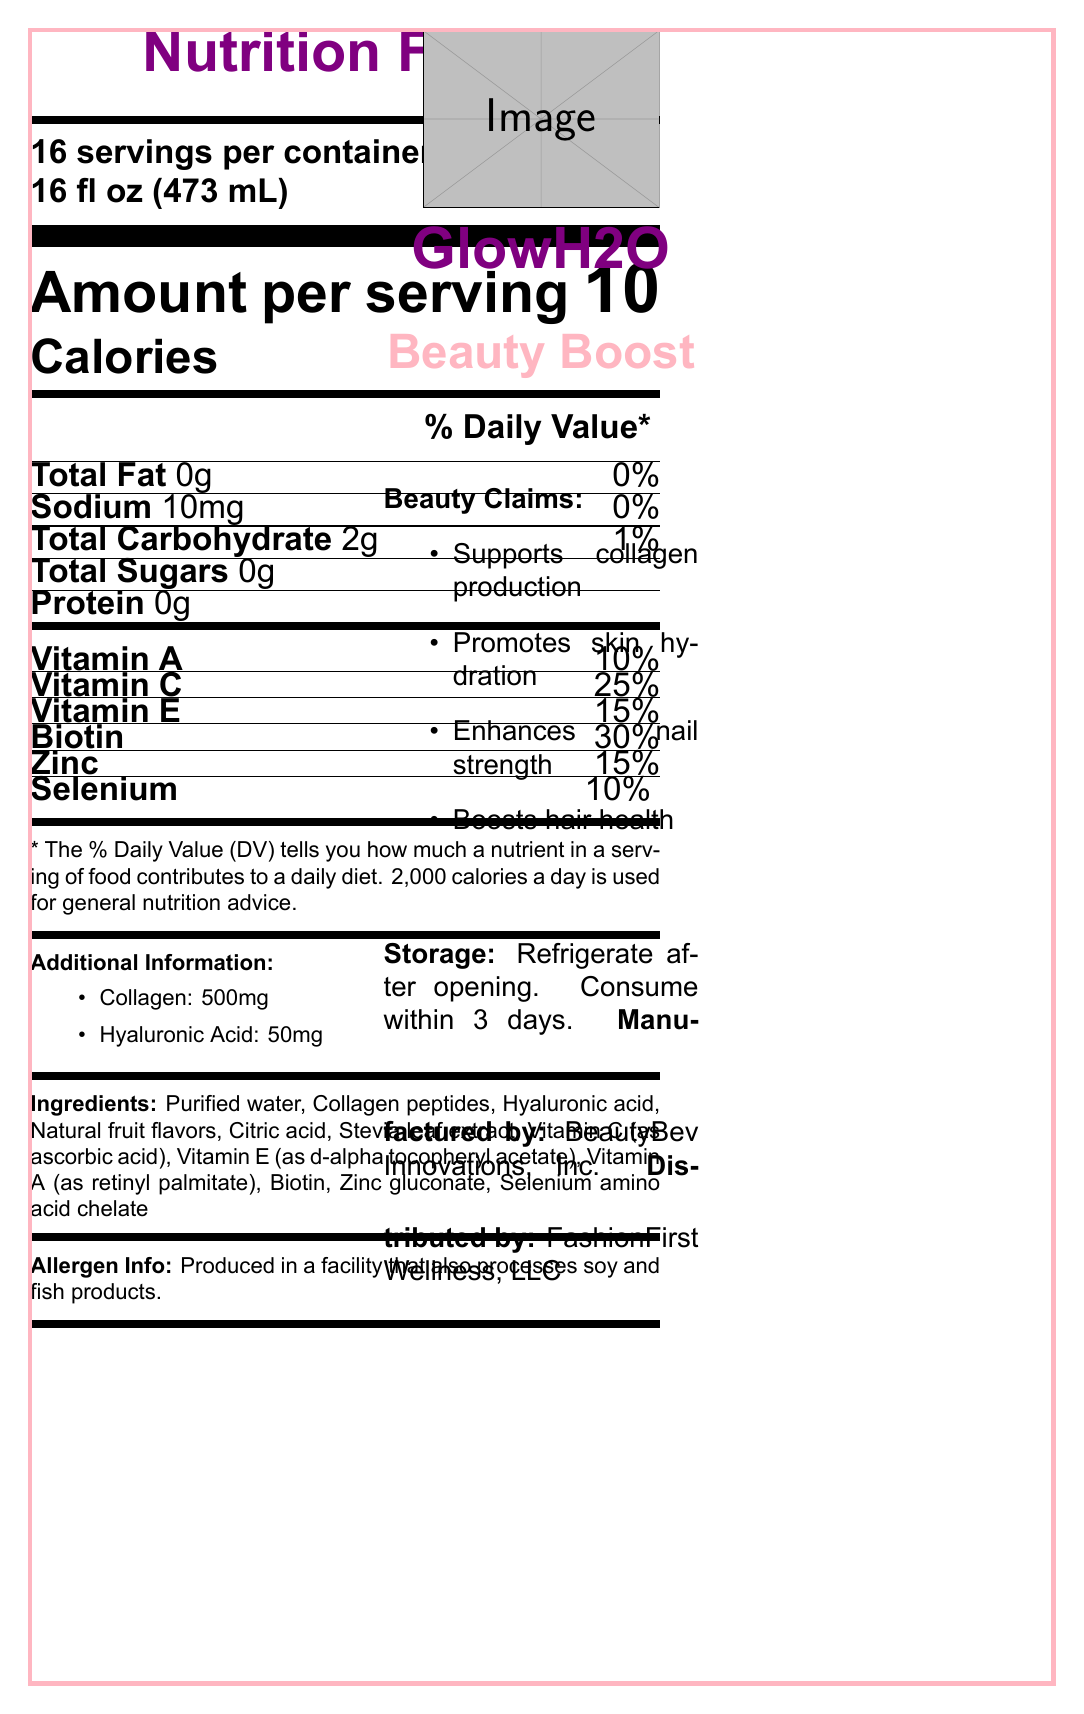What is the serving size of GlowH2O Beauty Boost? The serving size is clearly indicated on the document as "Serving size 16 fl oz (473 mL)".
Answer: 16 fl oz (473 mL) How many calories are in one serving of GlowH2O Beauty Boost? The nutrition facts section shows "Calories: 10" for one serving.
Answer: 10 calories What percentage of Daily Value (%DV) does Vitamin C provide in one serving? The nutrition facts section lists Vitamin C as contributing 25% of the Daily Value.
Answer: 25% DV How much biotin is in one serving of GlowH2O Beauty Boost? The nutrition facts section lists biotin as providing 30% of the Daily Value.
Answer: 30% DV What are the two main added beauty components in GlowH2O Beauty Boost? The document lists Collagen (500mg) and Hyaluronic Acid (50mg) under additional information.
Answer: Collagen (500mg) and Hyaluronic Acid (50mg) Which of the following vitamins is found in the highest percentage per serving in GlowH2O Beauty Boost? A. Vitamin A B. Vitamin C C. Vitamin E D. Selenium Vitamin C is listed as having a 25% Daily Value, which is higher compared to Vitamin A (10%), Vitamin E (15%), and Selenium (10%).
Answer: B. Vitamin C What is the primary key demographic targeted by GlowH2O Beauty Boost? A. Athletes B. Elderly women C. Fashion-conscious women aged 18-45 D. Children The document specifies the target demographic as "Fashion-conscious women aged 18-45".
Answer: C. Fashion-conscious women aged 18-45 Is GlowH2O Beauty Boost suitable for someone with a fish allergy? The allergen information states the product is produced in a facility that processes soy and fish products, thus not guaranteeing suitability for those with fish allergies.
Answer: No Does GlowH2O Beauty Boost claim to support collagen production? One of the marketing claims listed in the document is "Supports collagen production".
Answer: Yes Why should GlowH2O Beauty Boost be refrigerated after opening? The storage instructions specify "Refrigerate after opening" to ensure the product stays fresh and safe for consumption.
Answer: To maintain freshness and safety Describe the main idea of the document. The document provides detailed nutrition facts, marketing claims, storage instructions, allergen info, and demographic target, creating a comprehensive overview of the health and beauty benefits of GlowH2O Beauty Boost.
Answer: GlowH2O Beauty Boost is a vitamin-enriched bottled water designed to support skin, hair, and nail health with a variety of vitamins and beauty-enhancing compounds, aimed at fashion-conscious women aged 18-45. The product contains low calories, various vitamins, and additional components like collagen and hyaluronic acid to enhance beauty. What is the wholesale price of GlowH2O Beauty Boost? The document does not specify the wholesale price; only the retail price is mentioned.
Answer: Cannot be determined How long can GlowH2O Beauty Boost be stored unopened? The document lists the shelf life of the product as "12 months".
Answer: 12 months 